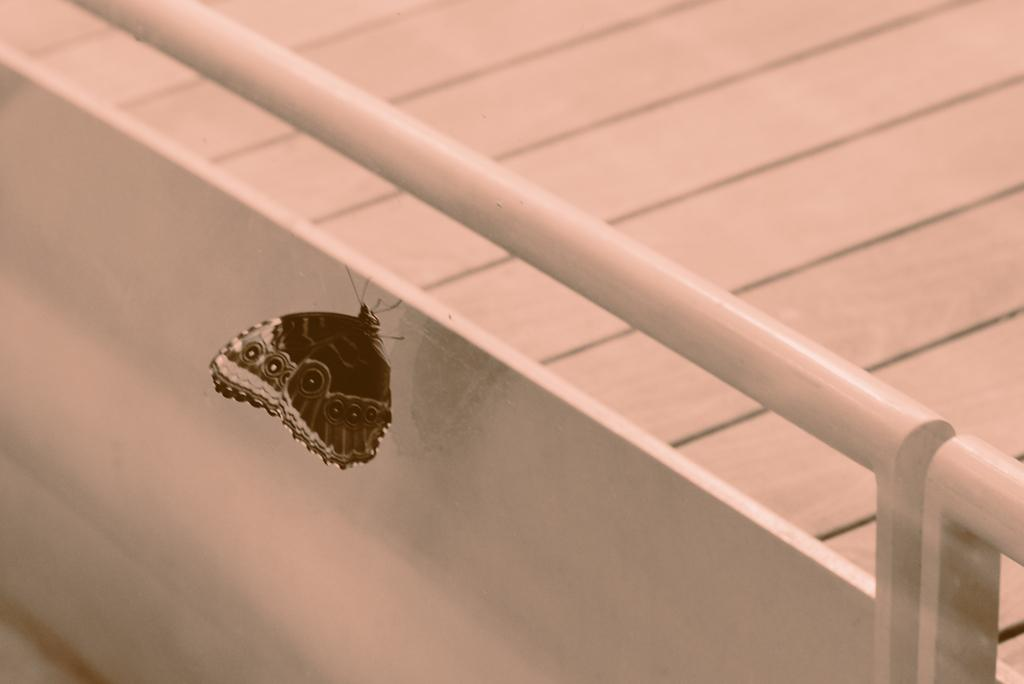What is the main subject of the image? There is a butterfly in the image. Where is the butterfly located? The butterfly is on a metal fence. What colors can be seen on the butterfly? The butterfly is black and white in color. What type of floor is visible in the image? There is a wooden floor visible in the image. What type of shoe is the butterfly wearing in the image? Butterflies do not wear shoes, so there is no shoe present in the image. 